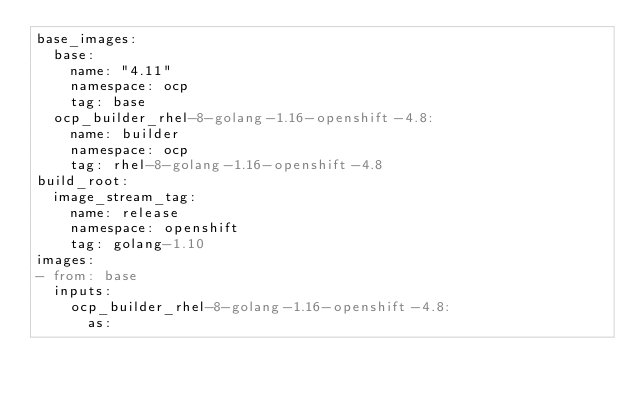<code> <loc_0><loc_0><loc_500><loc_500><_YAML_>base_images:
  base:
    name: "4.11"
    namespace: ocp
    tag: base
  ocp_builder_rhel-8-golang-1.16-openshift-4.8:
    name: builder
    namespace: ocp
    tag: rhel-8-golang-1.16-openshift-4.8
build_root:
  image_stream_tag:
    name: release
    namespace: openshift
    tag: golang-1.10
images:
- from: base
  inputs:
    ocp_builder_rhel-8-golang-1.16-openshift-4.8:
      as:</code> 